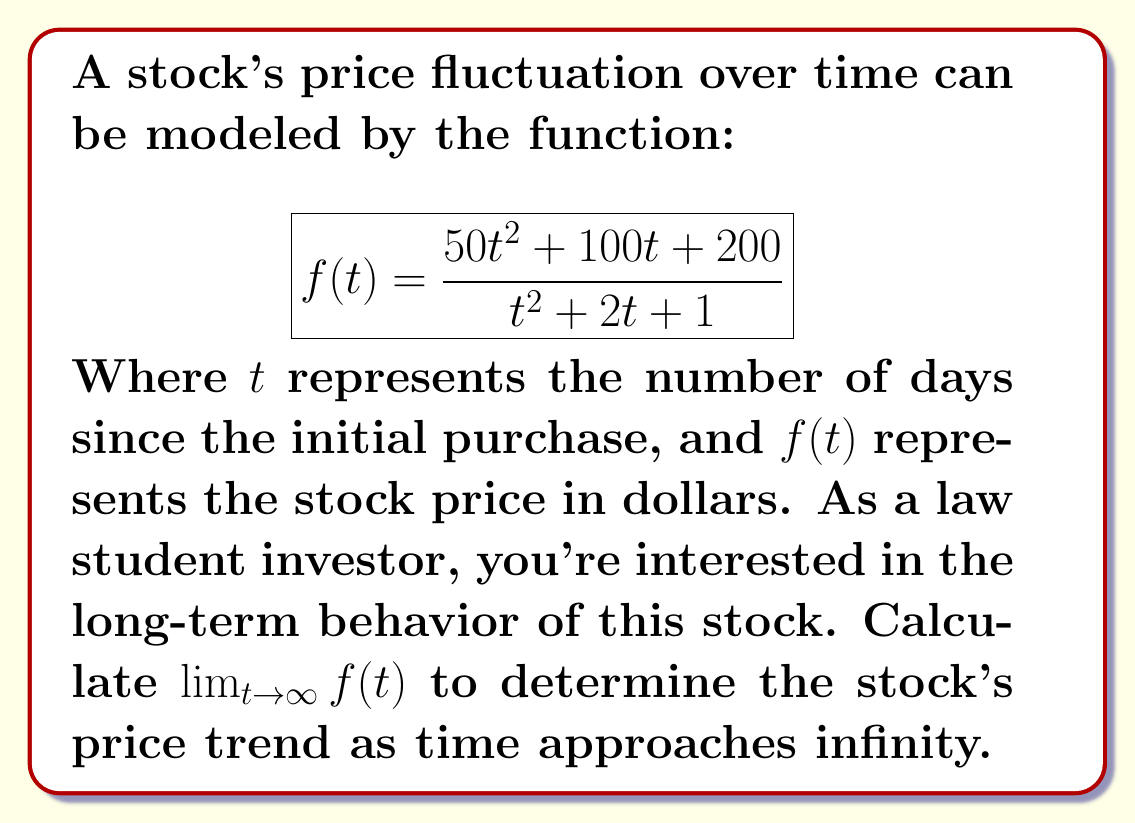What is the answer to this math problem? To find the limit of this rational function as $t$ approaches infinity, we can use the following steps:

1. Identify the highest degree terms in both the numerator and denominator:
   Numerator: $50t^2$
   Denominator: $t^2$

2. Divide both the numerator and denominator by the highest degree term of the denominator ($t^2$):

   $$\lim_{t \to \infty} f(t) = \lim_{t \to \infty} \frac{50t^2 + 100t + 200}{t^2 + 2t + 1}$$
   $$= \lim_{t \to \infty} \frac{50 + \frac{100}{t} + \frac{200}{t^2}}{1 + \frac{2}{t} + \frac{1}{t^2}}$$

3. As $t$ approaches infinity, the terms with $t$ in the denominator approach zero:

   $$\lim_{t \to \infty} \frac{50 + 0 + 0}{1 + 0 + 0} = \frac{50}{1} = 50$$

Therefore, as time approaches infinity, the stock price tends toward $50 dollars.
Answer: $\lim_{t \to \infty} f(t) = 50$ 